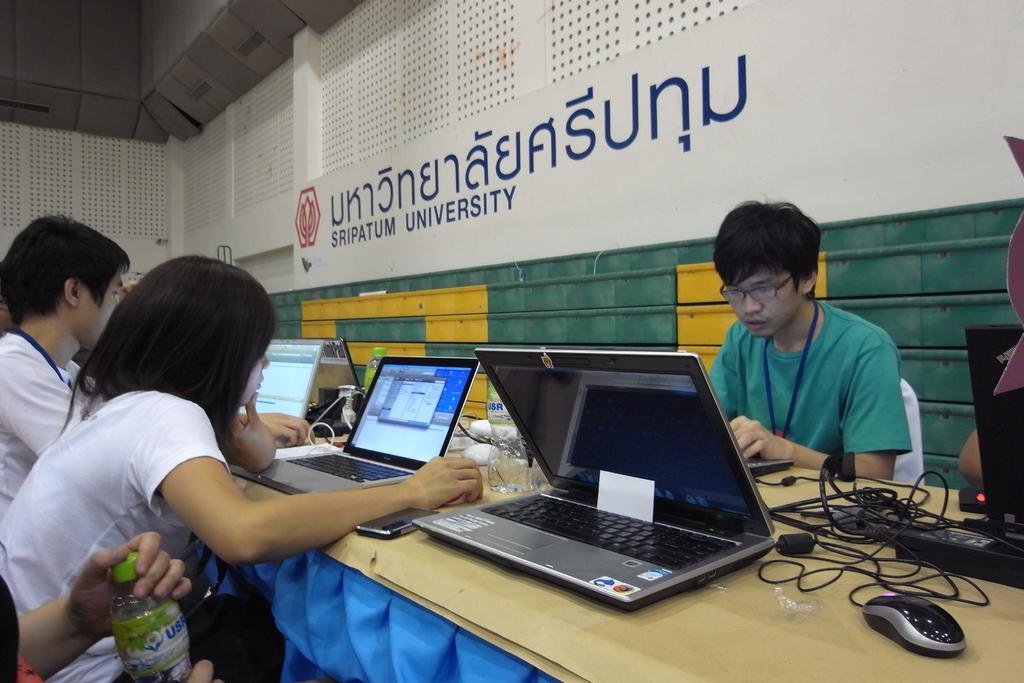What university is this?
Provide a succinct answer. Sripatum. 